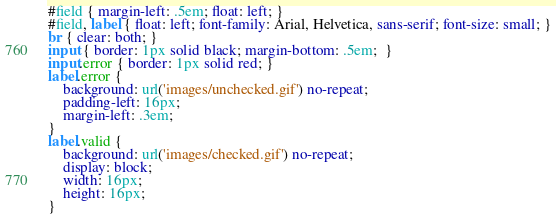Convert code to text. <code><loc_0><loc_0><loc_500><loc_500><_CSS_>#field { margin-left: .5em; float: left; }
#field, label { float: left; font-family: Arial, Helvetica, sans-serif; font-size: small; }
br { clear: both; }
input { border: 1px solid black; margin-bottom: .5em;  }
input.error { border: 1px solid red; }
label.error {
	background: url('images/unchecked.gif') no-repeat;
	padding-left: 16px;
	margin-left: .3em;
}
label.valid {
	background: url('images/checked.gif') no-repeat;
	display: block;
	width: 16px;
	height: 16px;
}</code> 